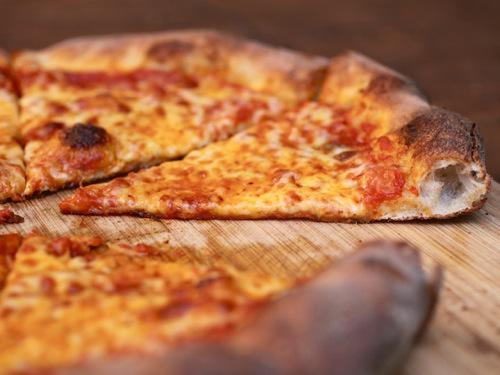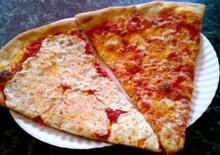The first image is the image on the left, the second image is the image on the right. Examine the images to the left and right. Is the description "There are two whole pizzas." accurate? Answer yes or no. No. 